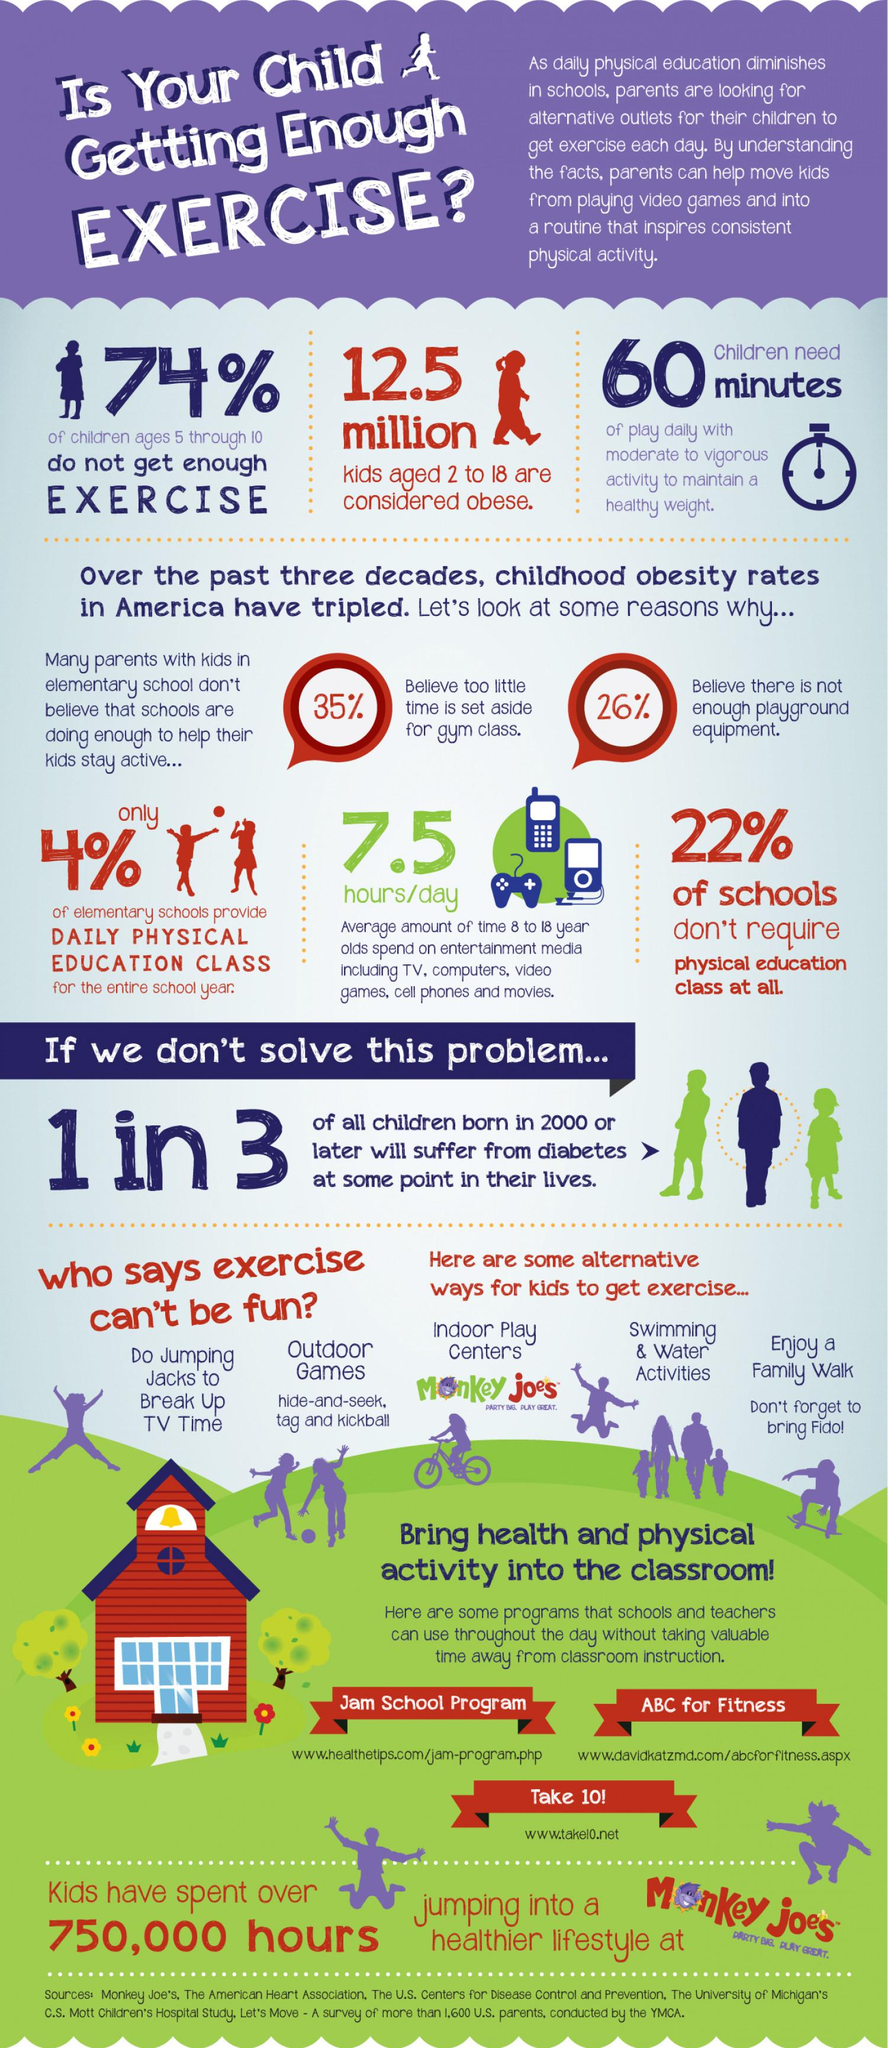Point out several critical features in this image. According to the survey, 22% of U.S. schools do not require physical education classes. According to a recent survey, only 4% of elementary schools in the United States provide daily physical education classes for the entire school year. According to a survey, a significant 74% of children aged 5-10 years in the U.S. do not get enough exercise. According to the survey, approximately 12.5 million children aged 2-18 years in the United States are considered obese. 